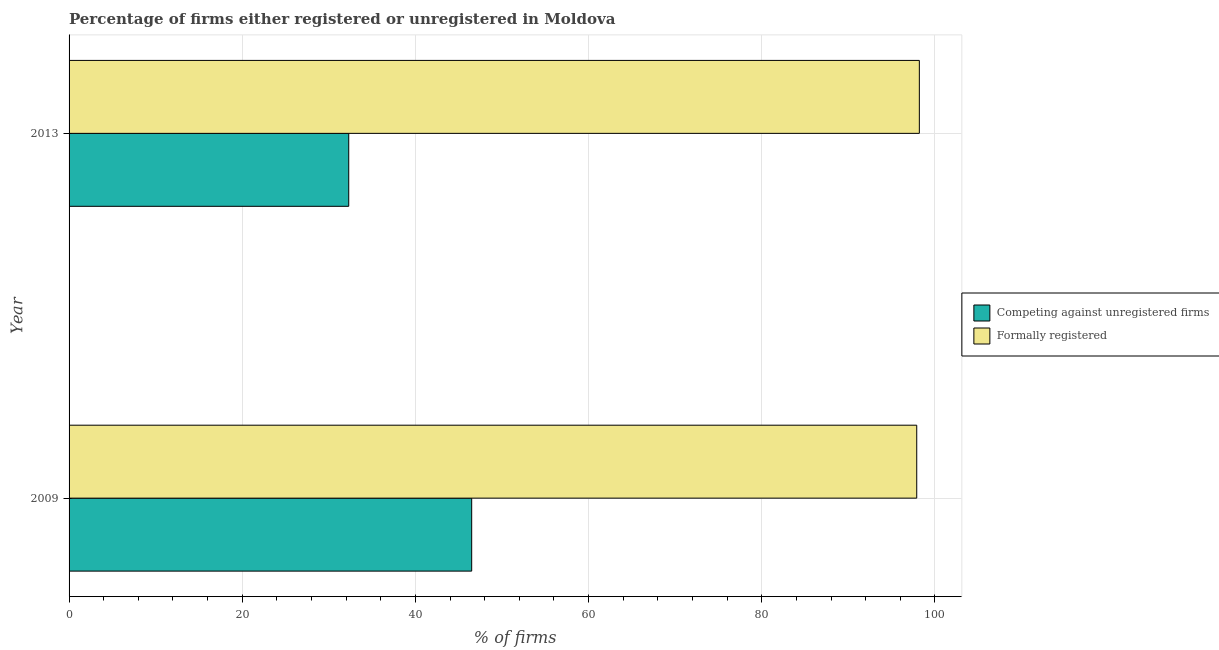How many different coloured bars are there?
Make the answer very short. 2. How many groups of bars are there?
Your answer should be compact. 2. Are the number of bars per tick equal to the number of legend labels?
Ensure brevity in your answer.  Yes. Are the number of bars on each tick of the Y-axis equal?
Your answer should be compact. Yes. What is the label of the 2nd group of bars from the top?
Your answer should be very brief. 2009. What is the percentage of formally registered firms in 2013?
Ensure brevity in your answer.  98.2. Across all years, what is the maximum percentage of formally registered firms?
Keep it short and to the point. 98.2. Across all years, what is the minimum percentage of registered firms?
Keep it short and to the point. 32.3. In which year was the percentage of registered firms maximum?
Make the answer very short. 2009. In which year was the percentage of formally registered firms minimum?
Provide a short and direct response. 2009. What is the total percentage of formally registered firms in the graph?
Keep it short and to the point. 196.1. What is the difference between the percentage of formally registered firms in 2009 and the percentage of registered firms in 2013?
Offer a terse response. 65.6. What is the average percentage of formally registered firms per year?
Ensure brevity in your answer.  98.05. In the year 2013, what is the difference between the percentage of registered firms and percentage of formally registered firms?
Keep it short and to the point. -65.9. What is the ratio of the percentage of formally registered firms in 2009 to that in 2013?
Your answer should be very brief. 1. Is the percentage of registered firms in 2009 less than that in 2013?
Keep it short and to the point. No. What does the 1st bar from the top in 2013 represents?
Give a very brief answer. Formally registered. What does the 1st bar from the bottom in 2009 represents?
Ensure brevity in your answer.  Competing against unregistered firms. Are all the bars in the graph horizontal?
Give a very brief answer. Yes. How many years are there in the graph?
Give a very brief answer. 2. What is the difference between two consecutive major ticks on the X-axis?
Your answer should be very brief. 20. Are the values on the major ticks of X-axis written in scientific E-notation?
Provide a short and direct response. No. Does the graph contain any zero values?
Give a very brief answer. No. Does the graph contain grids?
Make the answer very short. Yes. How many legend labels are there?
Make the answer very short. 2. What is the title of the graph?
Offer a very short reply. Percentage of firms either registered or unregistered in Moldova. Does "Under five" appear as one of the legend labels in the graph?
Keep it short and to the point. No. What is the label or title of the X-axis?
Offer a very short reply. % of firms. What is the label or title of the Y-axis?
Keep it short and to the point. Year. What is the % of firms of Competing against unregistered firms in 2009?
Offer a terse response. 46.5. What is the % of firms of Formally registered in 2009?
Your answer should be very brief. 97.9. What is the % of firms of Competing against unregistered firms in 2013?
Your answer should be very brief. 32.3. What is the % of firms in Formally registered in 2013?
Provide a succinct answer. 98.2. Across all years, what is the maximum % of firms in Competing against unregistered firms?
Offer a terse response. 46.5. Across all years, what is the maximum % of firms in Formally registered?
Provide a succinct answer. 98.2. Across all years, what is the minimum % of firms of Competing against unregistered firms?
Ensure brevity in your answer.  32.3. Across all years, what is the minimum % of firms of Formally registered?
Provide a short and direct response. 97.9. What is the total % of firms of Competing against unregistered firms in the graph?
Give a very brief answer. 78.8. What is the total % of firms in Formally registered in the graph?
Make the answer very short. 196.1. What is the difference between the % of firms of Competing against unregistered firms in 2009 and the % of firms of Formally registered in 2013?
Give a very brief answer. -51.7. What is the average % of firms of Competing against unregistered firms per year?
Offer a very short reply. 39.4. What is the average % of firms in Formally registered per year?
Keep it short and to the point. 98.05. In the year 2009, what is the difference between the % of firms of Competing against unregistered firms and % of firms of Formally registered?
Offer a terse response. -51.4. In the year 2013, what is the difference between the % of firms in Competing against unregistered firms and % of firms in Formally registered?
Ensure brevity in your answer.  -65.9. What is the ratio of the % of firms of Competing against unregistered firms in 2009 to that in 2013?
Ensure brevity in your answer.  1.44. What is the ratio of the % of firms of Formally registered in 2009 to that in 2013?
Your response must be concise. 1. What is the difference between the highest and the second highest % of firms of Competing against unregistered firms?
Provide a short and direct response. 14.2. What is the difference between the highest and the lowest % of firms in Competing against unregistered firms?
Offer a very short reply. 14.2. 